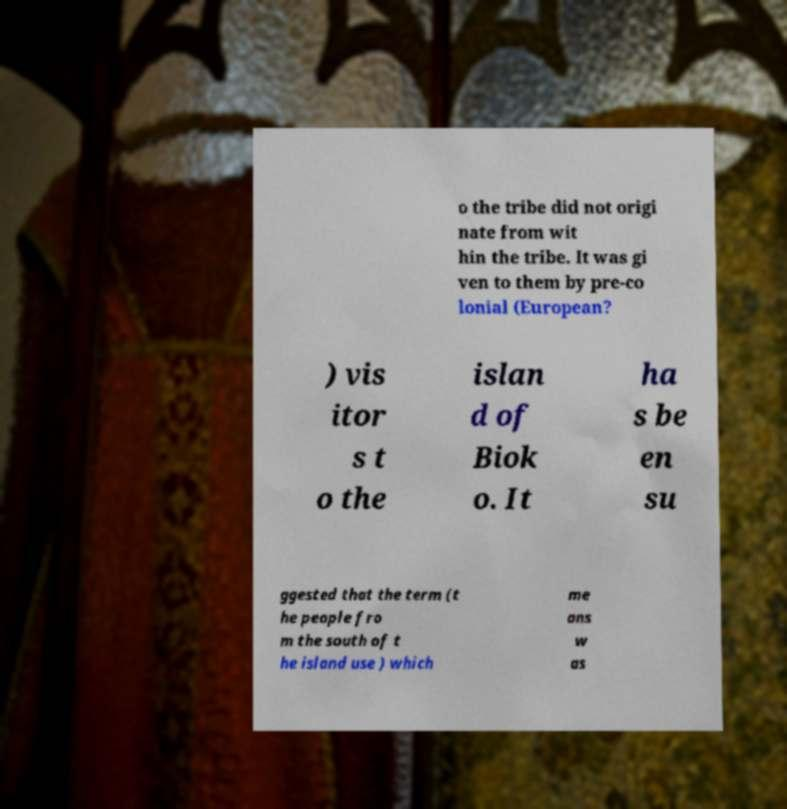Please identify and transcribe the text found in this image. o the tribe did not origi nate from wit hin the tribe. It was gi ven to them by pre-co lonial (European? ) vis itor s t o the islan d of Biok o. It ha s be en su ggested that the term (t he people fro m the south of t he island use ) which me ans w as 